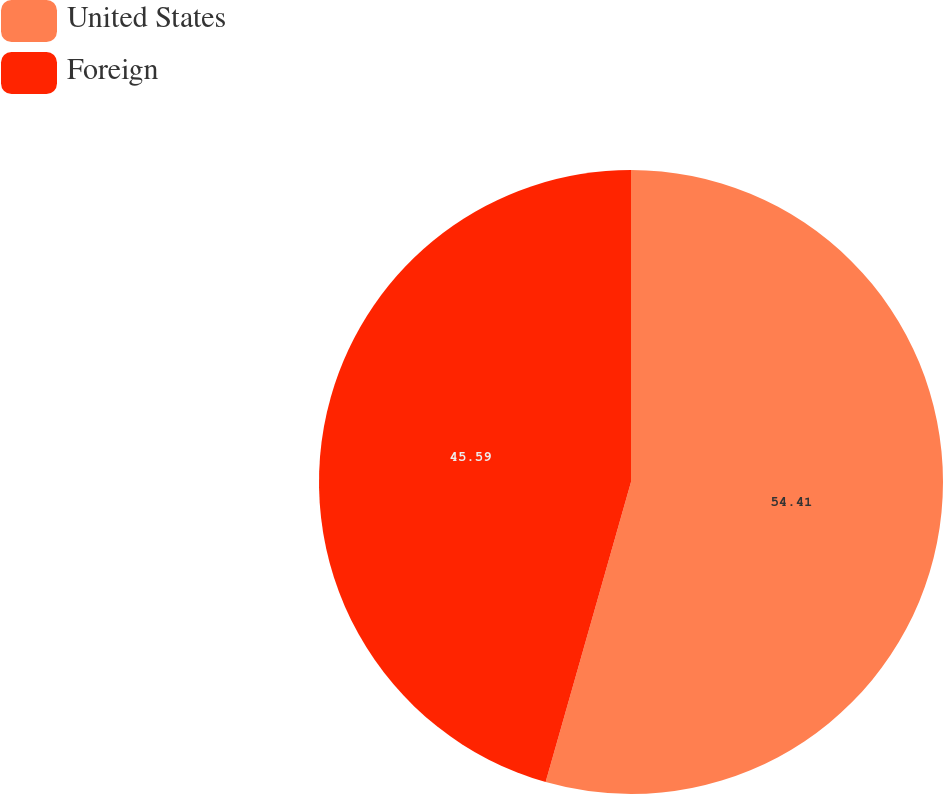Convert chart. <chart><loc_0><loc_0><loc_500><loc_500><pie_chart><fcel>United States<fcel>Foreign<nl><fcel>54.41%<fcel>45.59%<nl></chart> 